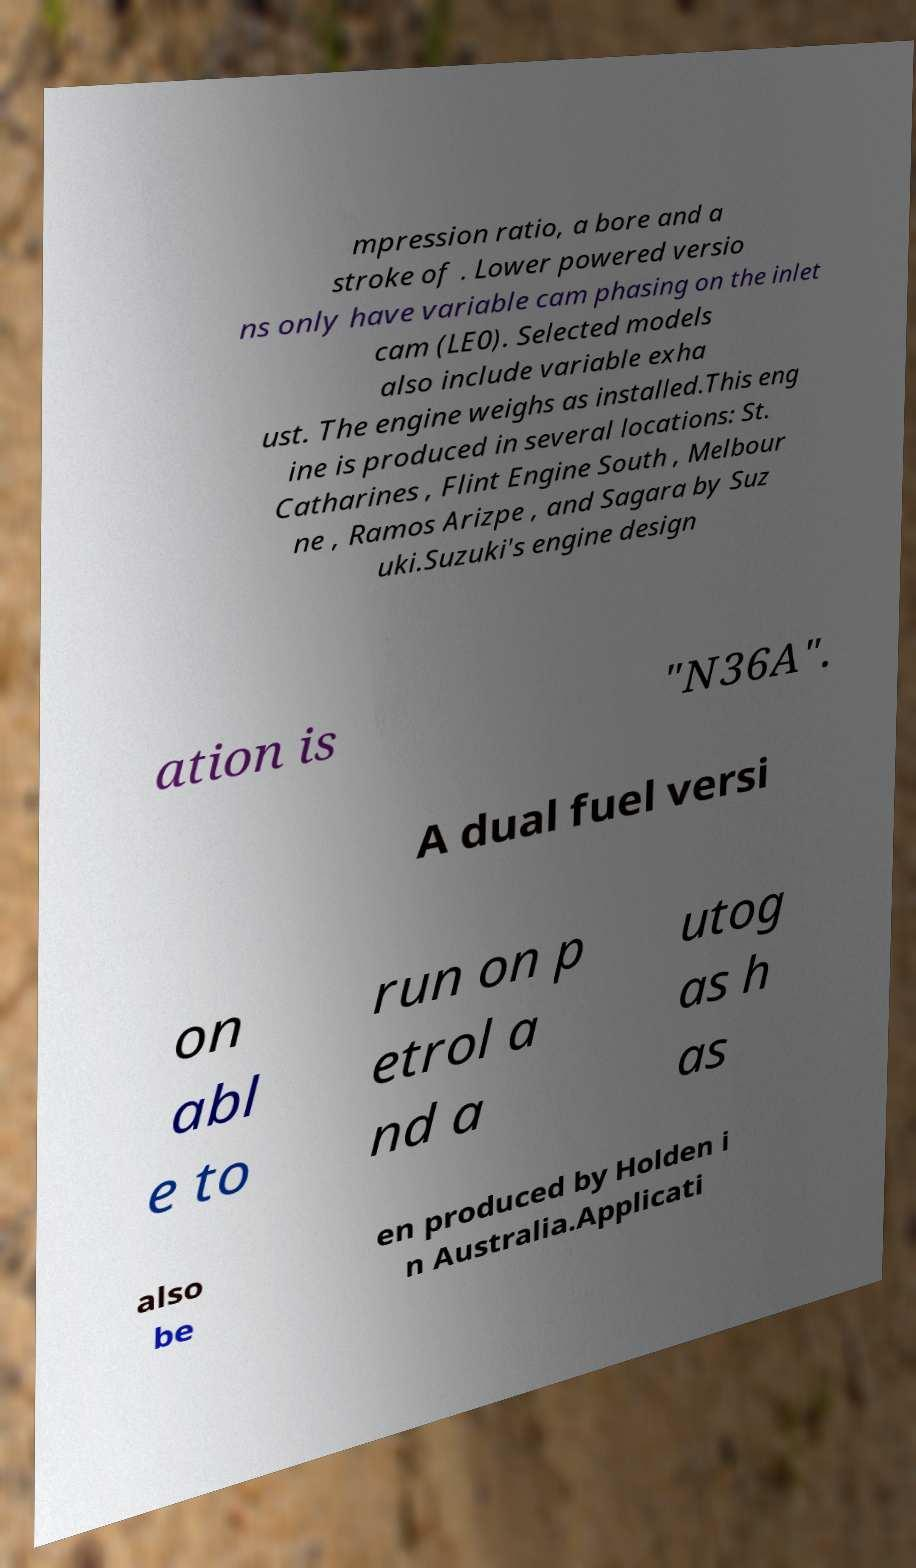For documentation purposes, I need the text within this image transcribed. Could you provide that? mpression ratio, a bore and a stroke of . Lower powered versio ns only have variable cam phasing on the inlet cam (LE0). Selected models also include variable exha ust. The engine weighs as installed.This eng ine is produced in several locations: St. Catharines , Flint Engine South , Melbour ne , Ramos Arizpe , and Sagara by Suz uki.Suzuki's engine design ation is "N36A". A dual fuel versi on abl e to run on p etrol a nd a utog as h as also be en produced by Holden i n Australia.Applicati 